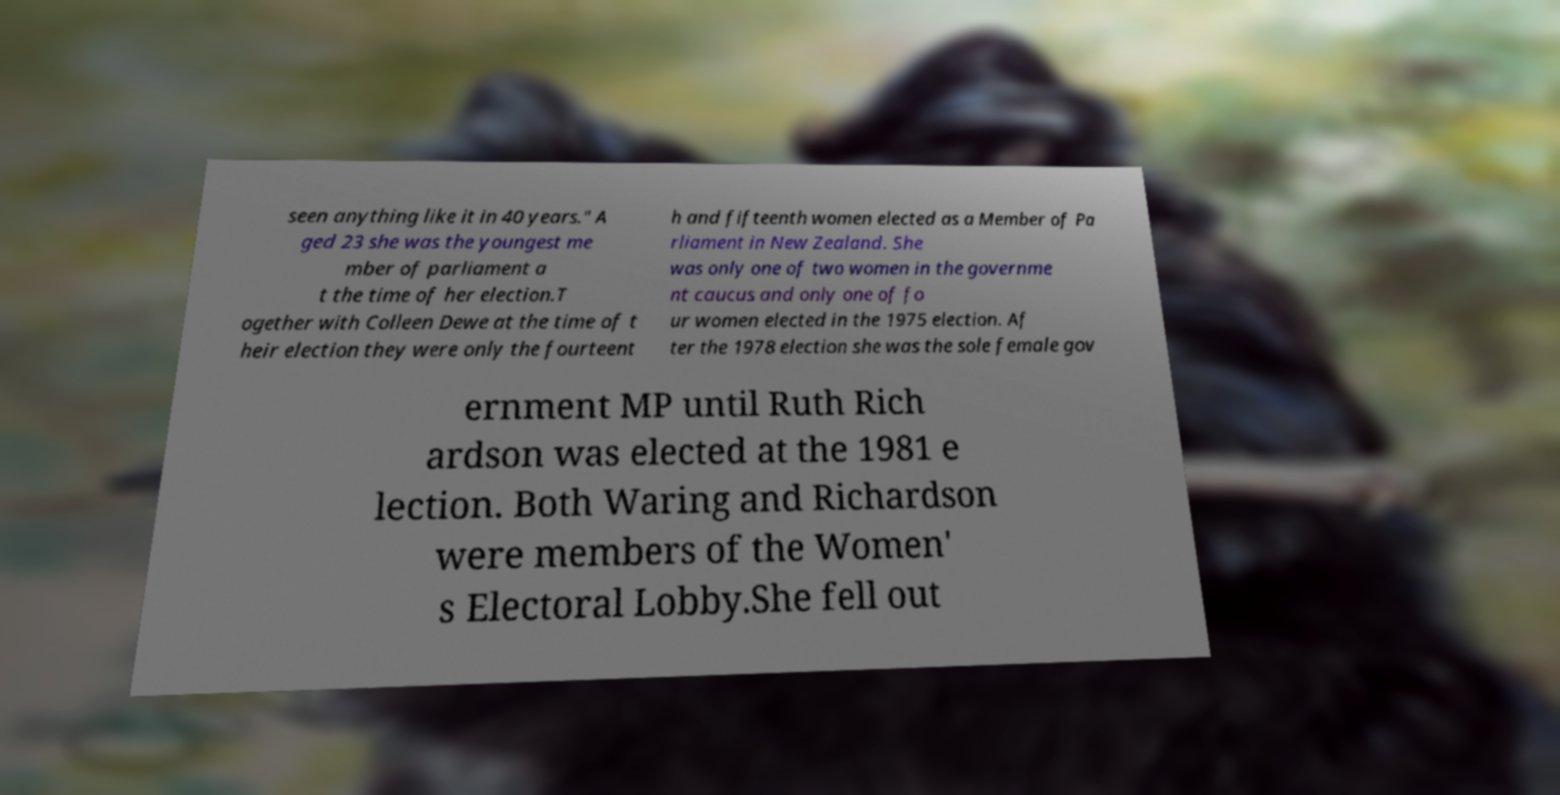There's text embedded in this image that I need extracted. Can you transcribe it verbatim? seen anything like it in 40 years." A ged 23 she was the youngest me mber of parliament a t the time of her election.T ogether with Colleen Dewe at the time of t heir election they were only the fourteent h and fifteenth women elected as a Member of Pa rliament in New Zealand. She was only one of two women in the governme nt caucus and only one of fo ur women elected in the 1975 election. Af ter the 1978 election she was the sole female gov ernment MP until Ruth Rich ardson was elected at the 1981 e lection. Both Waring and Richardson were members of the Women' s Electoral Lobby.She fell out 